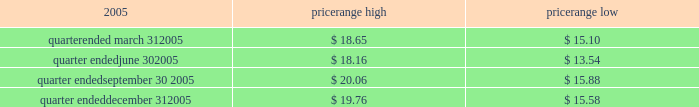Item 4 .
Submission of matters to a vote of security holders no matters were submitted to a vote of security holders during the fourth quarter of 2005 .
Part ii item 5 .
Market for the registrant 2019s common equity , related stockholder matters and issuer purchases of equity securities market information our series a common stock has traded on the new york stock exchange under the symbol 2018 2018ce 2019 2019 since january 21 , 2005 .
The closing sale price of our series a common stock , as reported by the new york stock exchange , on march 6 , 2006 was $ 20.98 .
The table sets forth the high and low intraday sales prices per share of our common stock , as reported by the new york stock exchange , for the periods indicated. .
Holders no shares of celanese 2019s series b common stock are issued and outstanding .
As of march 6 , 2006 , there were 51 holders of record of our series a common stock , and one holder of record of our perpetual preferred stock .
By including persons holding shares in broker accounts under street names , however , we estimate our shareholder base to be approximately 6800 as of march 6 , 2006 .
Dividend policy in july 2005 , our board of directors adopted a policy of declaring , subject to legally available funds , a quarterly cash dividend on each share of our common stock at an annual rate initially equal to approximately 1% ( 1 % ) of the $ 16 price per share in the initial public offering of our series a common stock ( or $ 0.16 per share ) unless our board of directors , in its sole discretion , determines otherwise , commencing the second quarter of 2005 .
Pursuant to this policy , the company paid the quarterly dividends of $ 0.04 per share on august 11 , 2005 , november 1 , 2005 and february 1 , 2006 .
Based on the number of outstanding shares of our series a common stock , the anticipated annual cash dividend is approximately $ 25 million .
However , there is no assurance that sufficient cash will be available in the future to pay such dividend .
Further , such dividends payable to holders of our series a common stock cannot be declared or paid nor can any funds be set aside for the payment thereof , unless we have paid or set aside funds for the payment of all accumulated and unpaid dividends with respect to the shares of our preferred stock , as described below .
Our board of directors may , at any time , modify or revoke our dividend policy on our series a common stock .
We are required under the terms of the preferred stock to pay scheduled quarterly dividends , subject to legally available funds .
For so long as the preferred stock remains outstanding , ( 1 ) we will not declare , pay or set apart funds for the payment of any dividend or other distribution with respect to any junior stock or parity stock and ( 2 ) neither we , nor any of our subsidiaries , will , subject to certain exceptions , redeem , purchase or otherwise acquire for consideration junior stock or parity stock through a sinking fund or otherwise , in each case unless we have paid or set apart funds for the payment of all accumulated and unpaid dividends with respect to the shares of preferred stock and any parity stock for all preceding dividend periods .
Pursuant to this policy , the company paid the quarterly dividends of $ 0.265625 on its 4.25% ( 4.25 % ) convertible perpetual preferred stock on august 1 , 2005 , november 1 , 2005 and february 1 , 2006 .
The anticipated annual cash dividend is approximately $ 10 million. .
What is the anticipated cash dividend for each quarter in millions? 
Rationale: the quarterly dividend you divide the annual by 4
Computations: (25 / 4)
Answer: 6.25. 